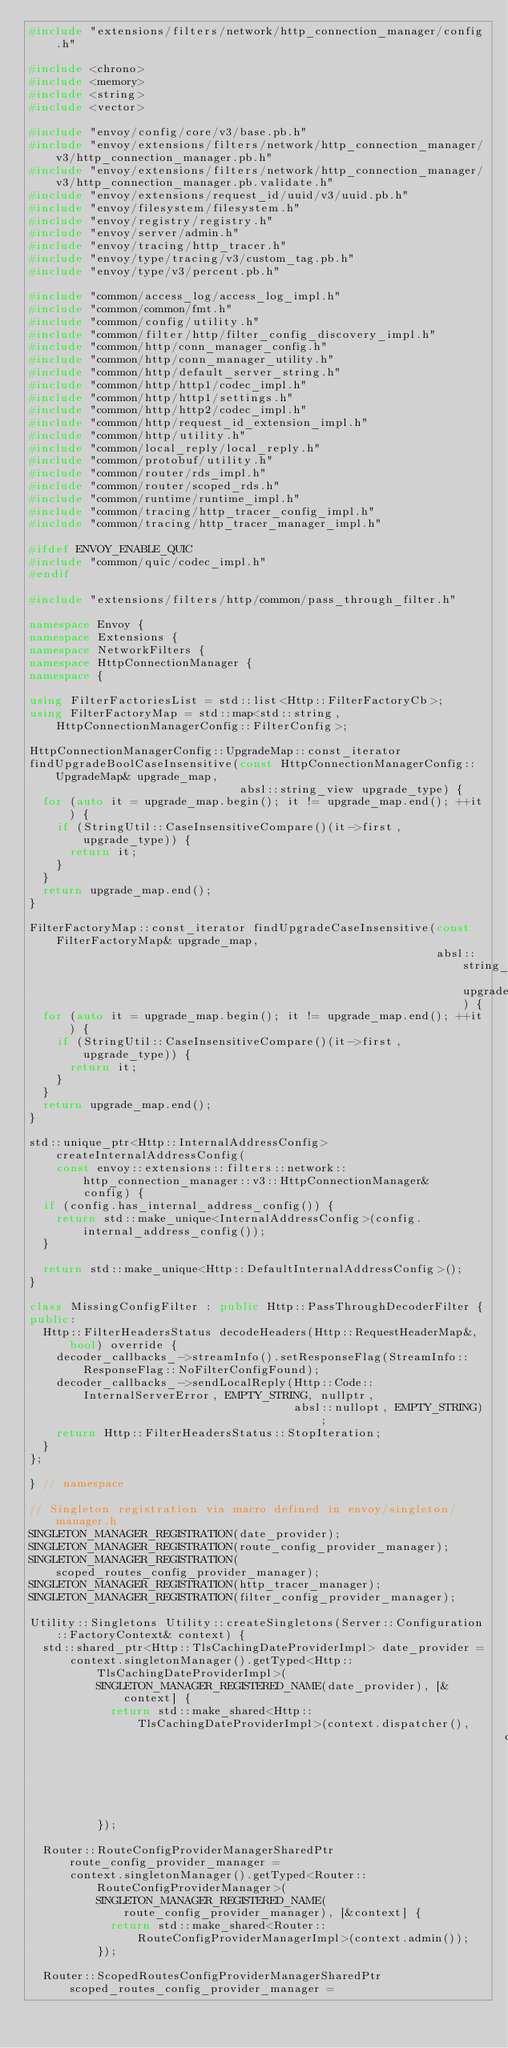<code> <loc_0><loc_0><loc_500><loc_500><_C++_>#include "extensions/filters/network/http_connection_manager/config.h"

#include <chrono>
#include <memory>
#include <string>
#include <vector>

#include "envoy/config/core/v3/base.pb.h"
#include "envoy/extensions/filters/network/http_connection_manager/v3/http_connection_manager.pb.h"
#include "envoy/extensions/filters/network/http_connection_manager/v3/http_connection_manager.pb.validate.h"
#include "envoy/extensions/request_id/uuid/v3/uuid.pb.h"
#include "envoy/filesystem/filesystem.h"
#include "envoy/registry/registry.h"
#include "envoy/server/admin.h"
#include "envoy/tracing/http_tracer.h"
#include "envoy/type/tracing/v3/custom_tag.pb.h"
#include "envoy/type/v3/percent.pb.h"

#include "common/access_log/access_log_impl.h"
#include "common/common/fmt.h"
#include "common/config/utility.h"
#include "common/filter/http/filter_config_discovery_impl.h"
#include "common/http/conn_manager_config.h"
#include "common/http/conn_manager_utility.h"
#include "common/http/default_server_string.h"
#include "common/http/http1/codec_impl.h"
#include "common/http/http1/settings.h"
#include "common/http/http2/codec_impl.h"
#include "common/http/request_id_extension_impl.h"
#include "common/http/utility.h"
#include "common/local_reply/local_reply.h"
#include "common/protobuf/utility.h"
#include "common/router/rds_impl.h"
#include "common/router/scoped_rds.h"
#include "common/runtime/runtime_impl.h"
#include "common/tracing/http_tracer_config_impl.h"
#include "common/tracing/http_tracer_manager_impl.h"

#ifdef ENVOY_ENABLE_QUIC
#include "common/quic/codec_impl.h"
#endif

#include "extensions/filters/http/common/pass_through_filter.h"

namespace Envoy {
namespace Extensions {
namespace NetworkFilters {
namespace HttpConnectionManager {
namespace {

using FilterFactoriesList = std::list<Http::FilterFactoryCb>;
using FilterFactoryMap = std::map<std::string, HttpConnectionManagerConfig::FilterConfig>;

HttpConnectionManagerConfig::UpgradeMap::const_iterator
findUpgradeBoolCaseInsensitive(const HttpConnectionManagerConfig::UpgradeMap& upgrade_map,
                               absl::string_view upgrade_type) {
  for (auto it = upgrade_map.begin(); it != upgrade_map.end(); ++it) {
    if (StringUtil::CaseInsensitiveCompare()(it->first, upgrade_type)) {
      return it;
    }
  }
  return upgrade_map.end();
}

FilterFactoryMap::const_iterator findUpgradeCaseInsensitive(const FilterFactoryMap& upgrade_map,
                                                            absl::string_view upgrade_type) {
  for (auto it = upgrade_map.begin(); it != upgrade_map.end(); ++it) {
    if (StringUtil::CaseInsensitiveCompare()(it->first, upgrade_type)) {
      return it;
    }
  }
  return upgrade_map.end();
}

std::unique_ptr<Http::InternalAddressConfig> createInternalAddressConfig(
    const envoy::extensions::filters::network::http_connection_manager::v3::HttpConnectionManager&
        config) {
  if (config.has_internal_address_config()) {
    return std::make_unique<InternalAddressConfig>(config.internal_address_config());
  }

  return std::make_unique<Http::DefaultInternalAddressConfig>();
}

class MissingConfigFilter : public Http::PassThroughDecoderFilter {
public:
  Http::FilterHeadersStatus decodeHeaders(Http::RequestHeaderMap&, bool) override {
    decoder_callbacks_->streamInfo().setResponseFlag(StreamInfo::ResponseFlag::NoFilterConfigFound);
    decoder_callbacks_->sendLocalReply(Http::Code::InternalServerError, EMPTY_STRING, nullptr,
                                       absl::nullopt, EMPTY_STRING);
    return Http::FilterHeadersStatus::StopIteration;
  }
};

} // namespace

// Singleton registration via macro defined in envoy/singleton/manager.h
SINGLETON_MANAGER_REGISTRATION(date_provider);
SINGLETON_MANAGER_REGISTRATION(route_config_provider_manager);
SINGLETON_MANAGER_REGISTRATION(scoped_routes_config_provider_manager);
SINGLETON_MANAGER_REGISTRATION(http_tracer_manager);
SINGLETON_MANAGER_REGISTRATION(filter_config_provider_manager);

Utility::Singletons Utility::createSingletons(Server::Configuration::FactoryContext& context) {
  std::shared_ptr<Http::TlsCachingDateProviderImpl> date_provider =
      context.singletonManager().getTyped<Http::TlsCachingDateProviderImpl>(
          SINGLETON_MANAGER_REGISTERED_NAME(date_provider), [&context] {
            return std::make_shared<Http::TlsCachingDateProviderImpl>(context.dispatcher(),
                                                                      context.threadLocal());
          });

  Router::RouteConfigProviderManagerSharedPtr route_config_provider_manager =
      context.singletonManager().getTyped<Router::RouteConfigProviderManager>(
          SINGLETON_MANAGER_REGISTERED_NAME(route_config_provider_manager), [&context] {
            return std::make_shared<Router::RouteConfigProviderManagerImpl>(context.admin());
          });

  Router::ScopedRoutesConfigProviderManagerSharedPtr scoped_routes_config_provider_manager =</code> 